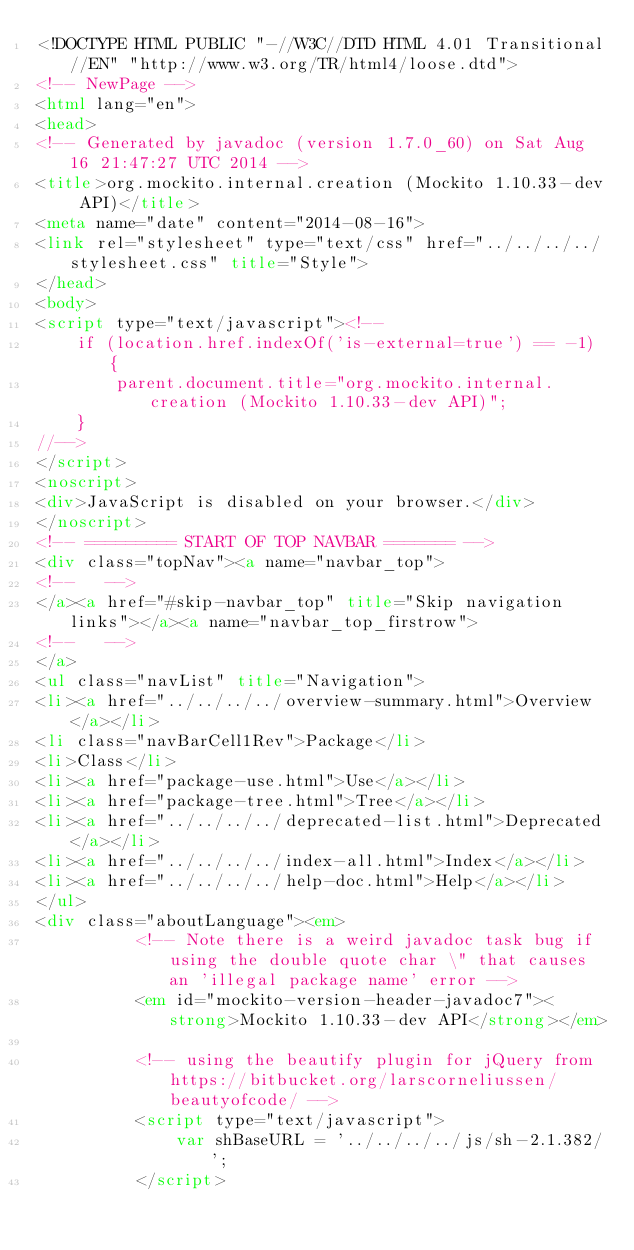<code> <loc_0><loc_0><loc_500><loc_500><_HTML_><!DOCTYPE HTML PUBLIC "-//W3C//DTD HTML 4.01 Transitional//EN" "http://www.w3.org/TR/html4/loose.dtd">
<!-- NewPage -->
<html lang="en">
<head>
<!-- Generated by javadoc (version 1.7.0_60) on Sat Aug 16 21:47:27 UTC 2014 -->
<title>org.mockito.internal.creation (Mockito 1.10.33-dev API)</title>
<meta name="date" content="2014-08-16">
<link rel="stylesheet" type="text/css" href="../../../../stylesheet.css" title="Style">
</head>
<body>
<script type="text/javascript"><!--
    if (location.href.indexOf('is-external=true') == -1) {
        parent.document.title="org.mockito.internal.creation (Mockito 1.10.33-dev API)";
    }
//-->
</script>
<noscript>
<div>JavaScript is disabled on your browser.</div>
</noscript>
<!-- ========= START OF TOP NAVBAR ======= -->
<div class="topNav"><a name="navbar_top">
<!--   -->
</a><a href="#skip-navbar_top" title="Skip navigation links"></a><a name="navbar_top_firstrow">
<!--   -->
</a>
<ul class="navList" title="Navigation">
<li><a href="../../../../overview-summary.html">Overview</a></li>
<li class="navBarCell1Rev">Package</li>
<li>Class</li>
<li><a href="package-use.html">Use</a></li>
<li><a href="package-tree.html">Tree</a></li>
<li><a href="../../../../deprecated-list.html">Deprecated</a></li>
<li><a href="../../../../index-all.html">Index</a></li>
<li><a href="../../../../help-doc.html">Help</a></li>
</ul>
<div class="aboutLanguage"><em>
          <!-- Note there is a weird javadoc task bug if using the double quote char \" that causes an 'illegal package name' error -->
          <em id="mockito-version-header-javadoc7"><strong>Mockito 1.10.33-dev API</strong></em>

          <!-- using the beautify plugin for jQuery from https://bitbucket.org/larscorneliussen/beautyofcode/ -->
          <script type="text/javascript">
              var shBaseURL = '../../../../js/sh-2.1.382/';
          </script></code> 